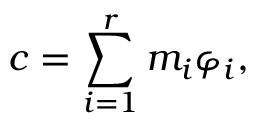<formula> <loc_0><loc_0><loc_500><loc_500>c = \sum _ { i = 1 } ^ { r } m _ { i } \varphi _ { i } ,</formula> 